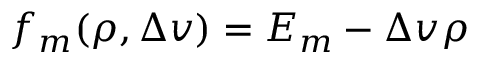Convert formula to latex. <formula><loc_0><loc_0><loc_500><loc_500>f _ { m } ( \rho , \Delta v ) = E _ { m } - \Delta v \rho</formula> 